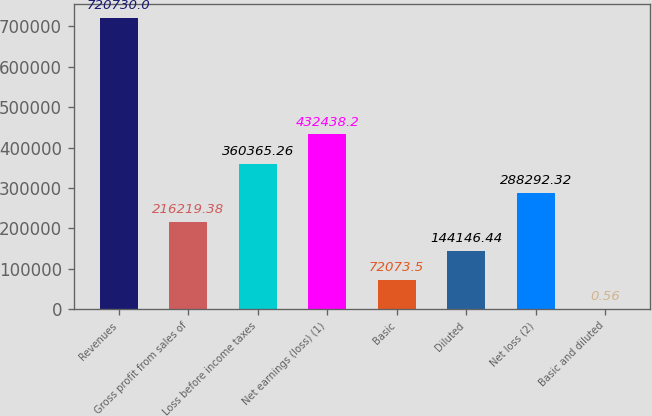<chart> <loc_0><loc_0><loc_500><loc_500><bar_chart><fcel>Revenues<fcel>Gross profit from sales of<fcel>Loss before income taxes<fcel>Net earnings (loss) (1)<fcel>Basic<fcel>Diluted<fcel>Net loss (2)<fcel>Basic and diluted<nl><fcel>720730<fcel>216219<fcel>360365<fcel>432438<fcel>72073.5<fcel>144146<fcel>288292<fcel>0.56<nl></chart> 